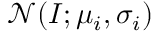<formula> <loc_0><loc_0><loc_500><loc_500>\mathcal { N } ( I ; \mu _ { i } , \sigma _ { i } )</formula> 